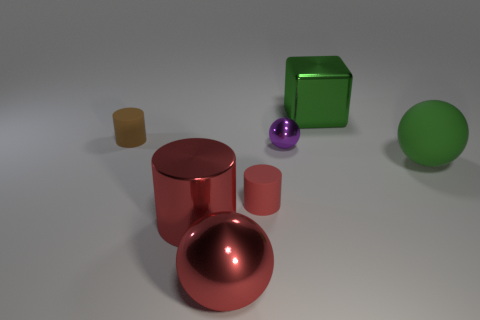Subtract all red spheres. How many spheres are left? 2 Add 2 large gray matte cubes. How many objects exist? 9 Subtract all red balls. How many balls are left? 2 Subtract 2 spheres. How many spheres are left? 1 Subtract all blue spheres. How many red cylinders are left? 2 Subtract all blocks. How many objects are left? 6 Subtract all tiny red objects. Subtract all big cyan metal cylinders. How many objects are left? 6 Add 1 large red metal things. How many large red metal things are left? 3 Add 4 large red things. How many large red things exist? 6 Subtract 0 brown spheres. How many objects are left? 7 